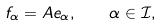<formula> <loc_0><loc_0><loc_500><loc_500>f _ { \alpha } = A e _ { \alpha } , \quad \alpha \in \mathcal { I } ,</formula> 